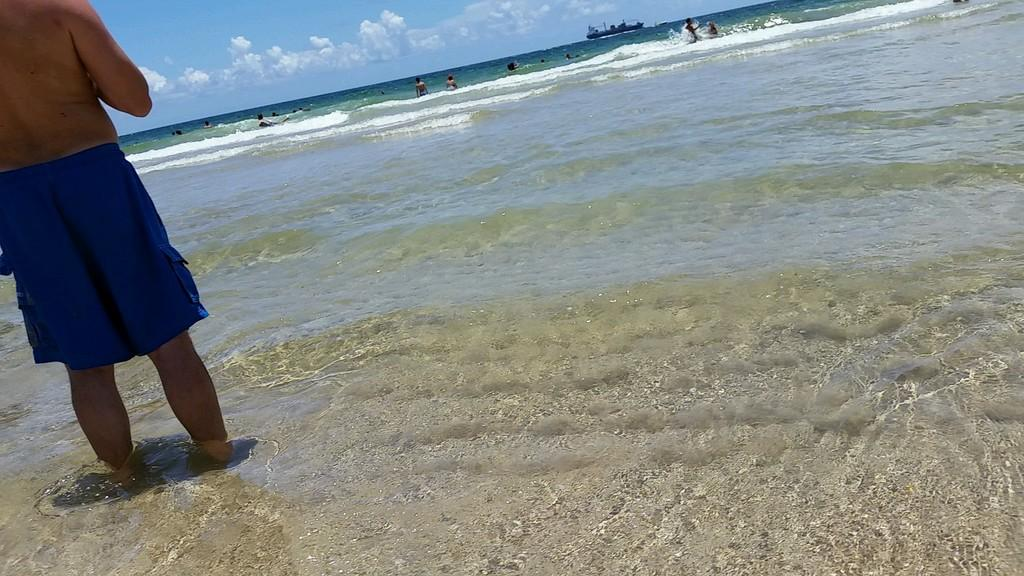What is the person in the image doing? The person is standing in the water. Are there any other people in the water? Yes, there is a group of people in the water. What else can be seen on the water? There is a boat on the water. What can be seen in the background of the image? The sky is visible in the background of the image. Can you see a jar filled with water in the image? There is no jar filled with water present in the image. Are there any giraffes visible in the image? There are no giraffes present in the image. 